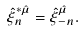<formula> <loc_0><loc_0><loc_500><loc_500>\hat { \xi } ^ { \ast \hat { \mu } } _ { n } = \hat { \xi } ^ { \hat { \mu } } _ { - n } .</formula> 